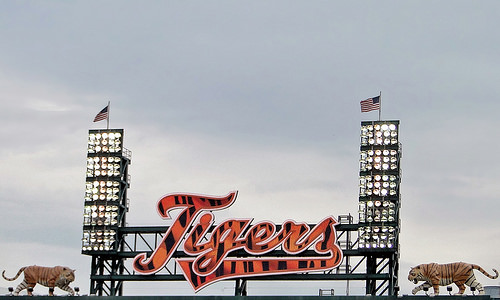<image>
Is the flag behind the light? No. The flag is not behind the light. From this viewpoint, the flag appears to be positioned elsewhere in the scene. 